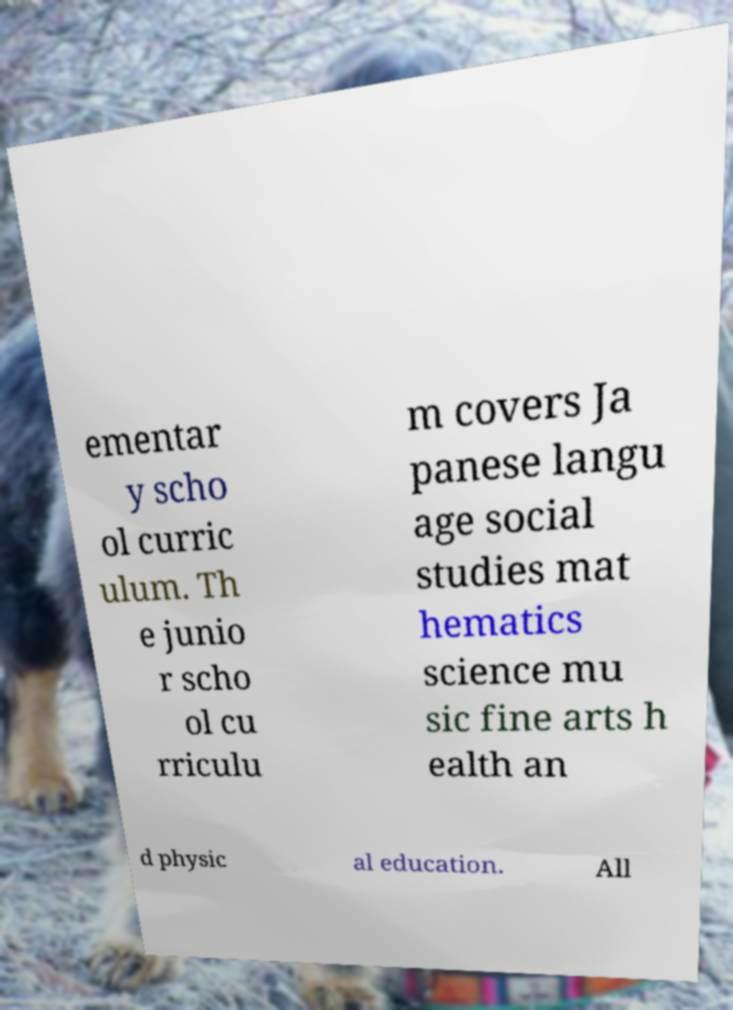Can you accurately transcribe the text from the provided image for me? ementar y scho ol curric ulum. Th e junio r scho ol cu rriculu m covers Ja panese langu age social studies mat hematics science mu sic fine arts h ealth an d physic al education. All 